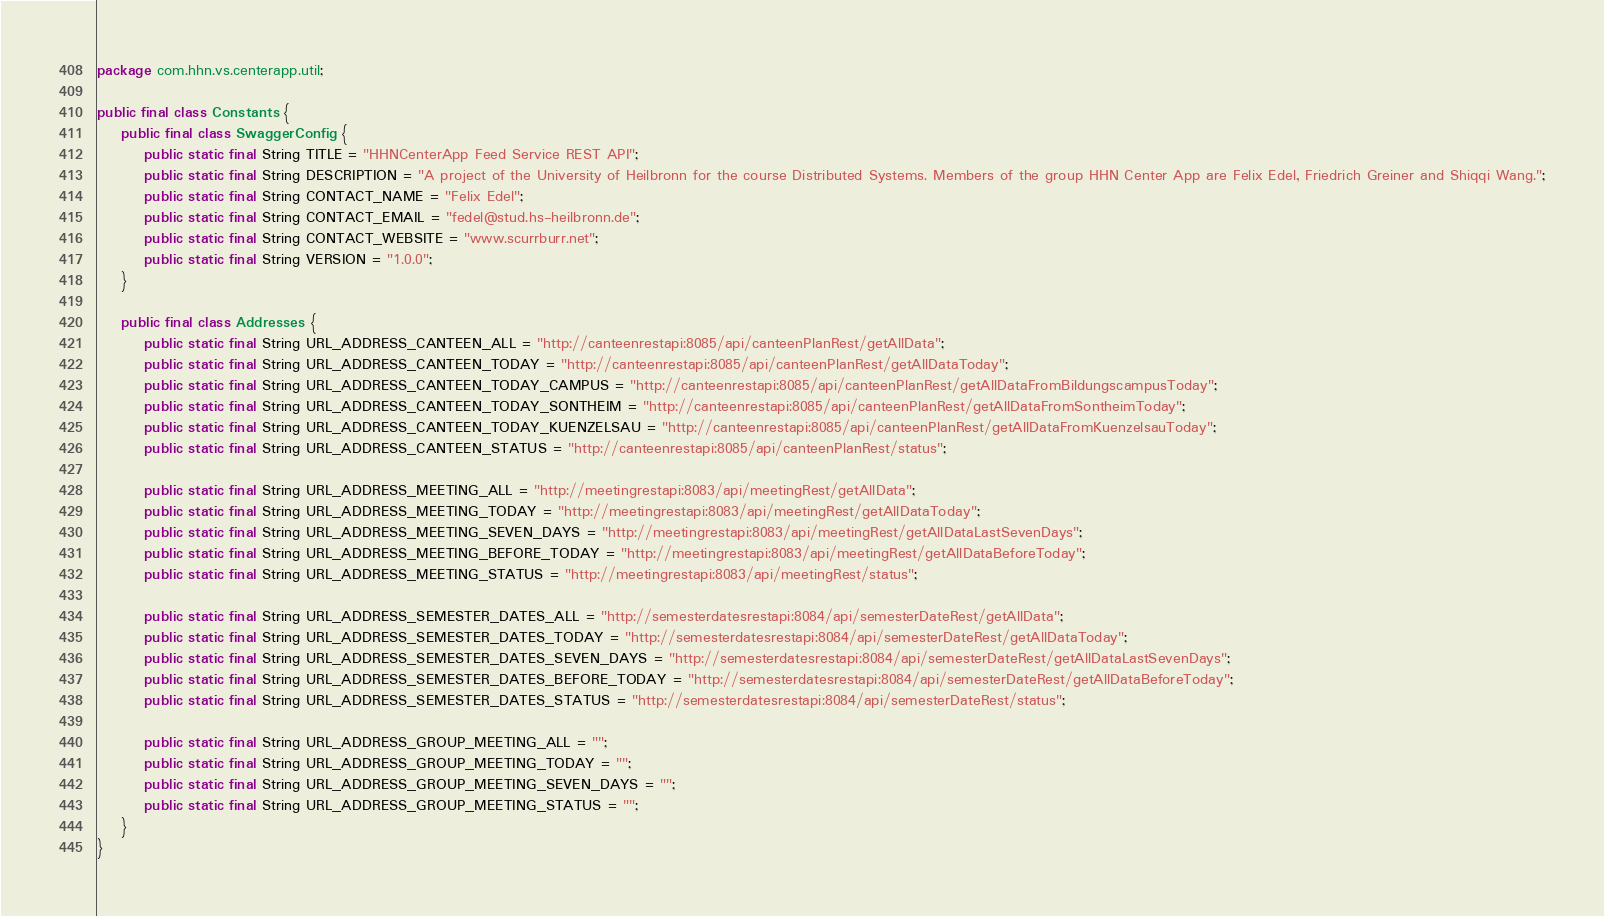<code> <loc_0><loc_0><loc_500><loc_500><_Java_>package com.hhn.vs.centerapp.util;

public final class Constants {
	public final class SwaggerConfig {
		public static final String TITLE = "HHNCenterApp Feed Service REST API";
		public static final String DESCRIPTION = "A project of the University of Heilbronn for the course Distributed Systems. Members of the group HHN Center App are Felix Edel, Friedrich Greiner and Shiqqi Wang.";
		public static final String CONTACT_NAME = "Felix Edel";
		public static final String CONTACT_EMAIL = "fedel@stud.hs-heilbronn.de";
		public static final String CONTACT_WEBSITE = "www.scurrburr.net"; 
		public static final String VERSION = "1.0.0"; 
	}

	public final class Addresses {
		public static final String URL_ADDRESS_CANTEEN_ALL = "http://canteenrestapi:8085/api/canteenPlanRest/getAllData";
		public static final String URL_ADDRESS_CANTEEN_TODAY = "http://canteenrestapi:8085/api/canteenPlanRest/getAllDataToday";
		public static final String URL_ADDRESS_CANTEEN_TODAY_CAMPUS = "http://canteenrestapi:8085/api/canteenPlanRest/getAllDataFromBildungscampusToday";
		public static final String URL_ADDRESS_CANTEEN_TODAY_SONTHEIM = "http://canteenrestapi:8085/api/canteenPlanRest/getAllDataFromSontheimToday";
		public static final String URL_ADDRESS_CANTEEN_TODAY_KUENZELSAU = "http://canteenrestapi:8085/api/canteenPlanRest/getAllDataFromKuenzelsauToday";
		public static final String URL_ADDRESS_CANTEEN_STATUS = "http://canteenrestapi:8085/api/canteenPlanRest/status";

		public static final String URL_ADDRESS_MEETING_ALL = "http://meetingrestapi:8083/api/meetingRest/getAllData";
		public static final String URL_ADDRESS_MEETING_TODAY = "http://meetingrestapi:8083/api/meetingRest/getAllDataToday";
		public static final String URL_ADDRESS_MEETING_SEVEN_DAYS = "http://meetingrestapi:8083/api/meetingRest/getAllDataLastSevenDays";
		public static final String URL_ADDRESS_MEETING_BEFORE_TODAY = "http://meetingrestapi:8083/api/meetingRest/getAllDataBeforeToday";
		public static final String URL_ADDRESS_MEETING_STATUS = "http://meetingrestapi:8083/api/meetingRest/status";

		public static final String URL_ADDRESS_SEMESTER_DATES_ALL = "http://semesterdatesrestapi:8084/api/semesterDateRest/getAllData";
		public static final String URL_ADDRESS_SEMESTER_DATES_TODAY = "http://semesterdatesrestapi:8084/api/semesterDateRest/getAllDataToday";
		public static final String URL_ADDRESS_SEMESTER_DATES_SEVEN_DAYS = "http://semesterdatesrestapi:8084/api/semesterDateRest/getAllDataLastSevenDays";
		public static final String URL_ADDRESS_SEMESTER_DATES_BEFORE_TODAY = "http://semesterdatesrestapi:8084/api/semesterDateRest/getAllDataBeforeToday";
		public static final String URL_ADDRESS_SEMESTER_DATES_STATUS = "http://semesterdatesrestapi:8084/api/semesterDateRest/status";

		public static final String URL_ADDRESS_GROUP_MEETING_ALL = "";
		public static final String URL_ADDRESS_GROUP_MEETING_TODAY = "";
		public static final String URL_ADDRESS_GROUP_MEETING_SEVEN_DAYS = "";
		public static final String URL_ADDRESS_GROUP_MEETING_STATUS = "";
	}
}
</code> 